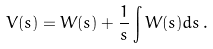<formula> <loc_0><loc_0><loc_500><loc_500>V ( s ) = W ( s ) + \frac { 1 } { s } \int W ( s ) d s \, .</formula> 